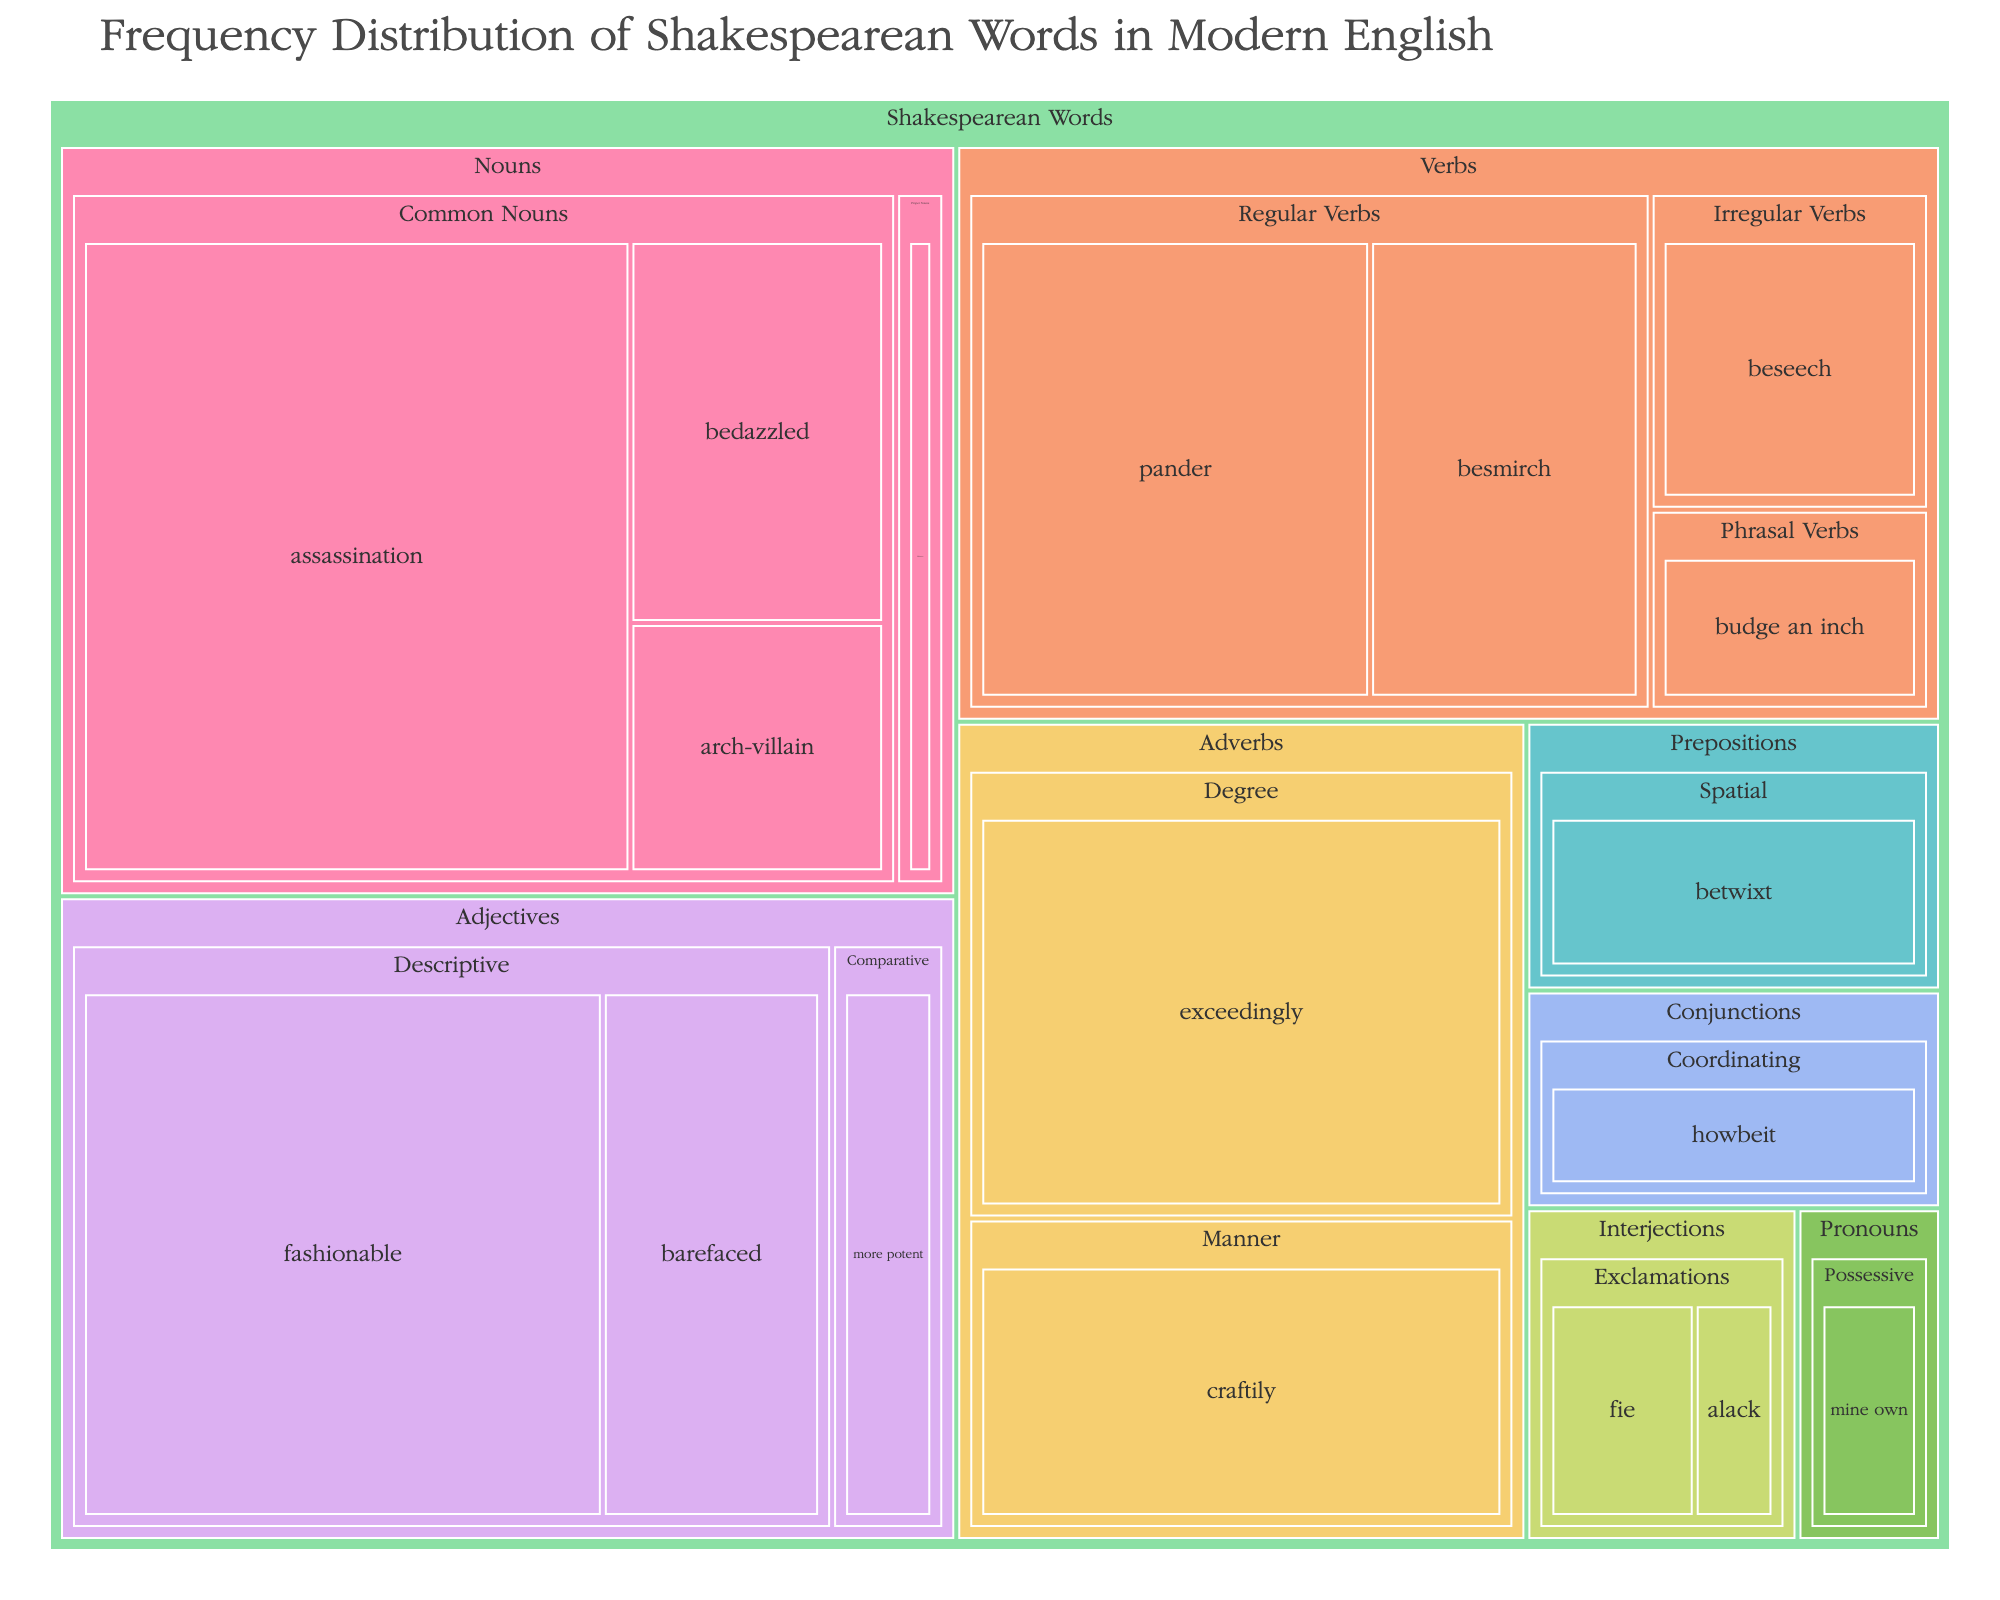what is the title of the plot? The title is usually displayed prominently at the top of the plot. In this case, it is "Frequency Distribution of Shakespearean Words in Modern English".
Answer: Frequency Distribution of Shakespearean Words in Modern English How many categories are represented in the treemap? The categories are represented by the different colors in the treemap. There are 8 categories: Nouns, Verbs, Adjectives, Adverbs, Pronouns, Interjections, Conjunctions, and Prepositions.
Answer: 8 Which Shakespearean word has the highest frequency? By examining the size of the rectangles in the treemap, we can identify that "assassination" from the Common Nouns category has the highest frequency, which is labeled as 82.
Answer: assassination What is the total frequency of all words in the "Adverbs" category? To find the total frequency, sum the frequencies of all words in the "Adverbs" category: craftily (36) and exceedingly (52). So, 36 + 52 = 88.
Answer: 88 Which category has the largest number of parts of speech? To answer this, look at how many different parts of speech subdivisions each category has. The 'Verbs' category has the most parts of speech subdivisions: Regular Verbs, Irregular Verbs, and Phrasal Verbs (3).
Answer: Verbs How does the frequency of "fashionable" compare to "barefaced"? Locate both words in the tree map under the Adjectives category. "fashionable" has a frequency of 67 and "barefaced" has a frequency of 28. Therefore, "fashionable" is 39 more frequent than "barefaced" (67 - 28 = 39).
Answer: 39 more frequent Which "Interjections" word has the lower frequency, "alack" or "fie"? Locate the rectangles for "alack" and "fie" under the Interjections category. "alack" has the lower frequency compared to "fie" as it has a frequency of 6 versus 11 for "fie".
Answer: alack What is the median frequency of the words in the "Nouns" category? First, list out the frequencies of the words in the Nouns category in order: 7, 15, 23, 82. The median is the average of the two middle numbers when sorted, which in this case are 15 and 23. Therefore, the median is (15 + 23)/2 = 19.
Answer: 19 In the "Verbs" category, which part of speech has the highest total frequency? Sum the frequencies for each part of speech under Verbs: Regular Verbs: 31 + 45, Irregular Verbs: 19, Phrasal Verbs: 12. Regular Verbs have the highest total frequency of 76 (31+45).
Answer: Regular Verbs 